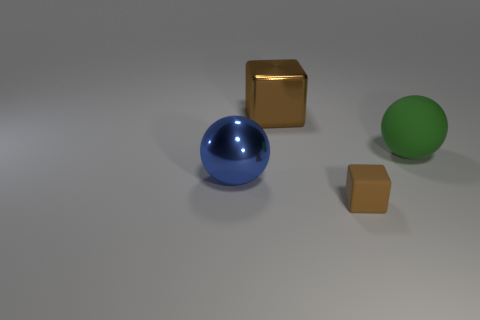Add 3 large red cubes. How many objects exist? 7 Subtract 0 yellow spheres. How many objects are left? 4 Subtract all big red metal things. Subtract all blue things. How many objects are left? 3 Add 2 small brown objects. How many small brown objects are left? 3 Add 2 tiny matte cubes. How many tiny matte cubes exist? 3 